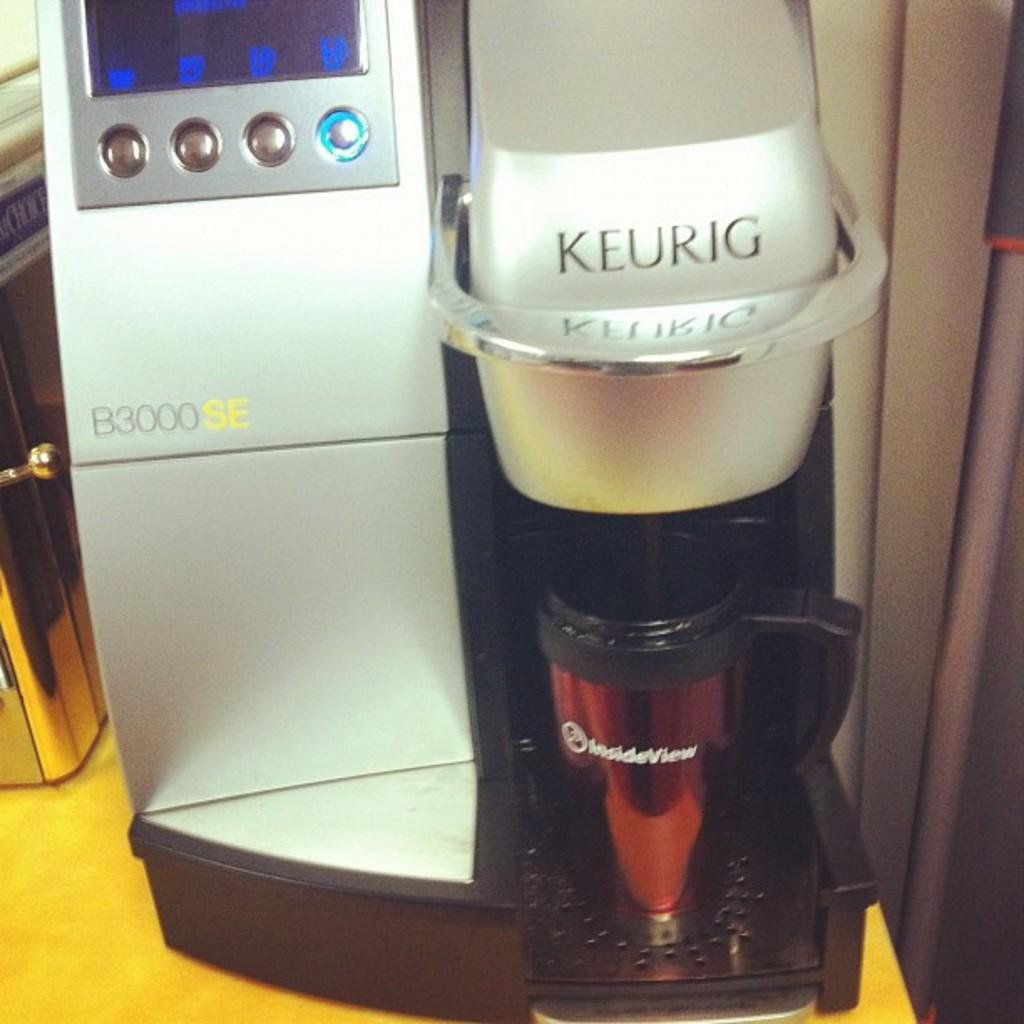Provide a one-sentence caption for the provided image. A Keurig B3000SE machine is dispensing something into an InsideView coffee mug. 